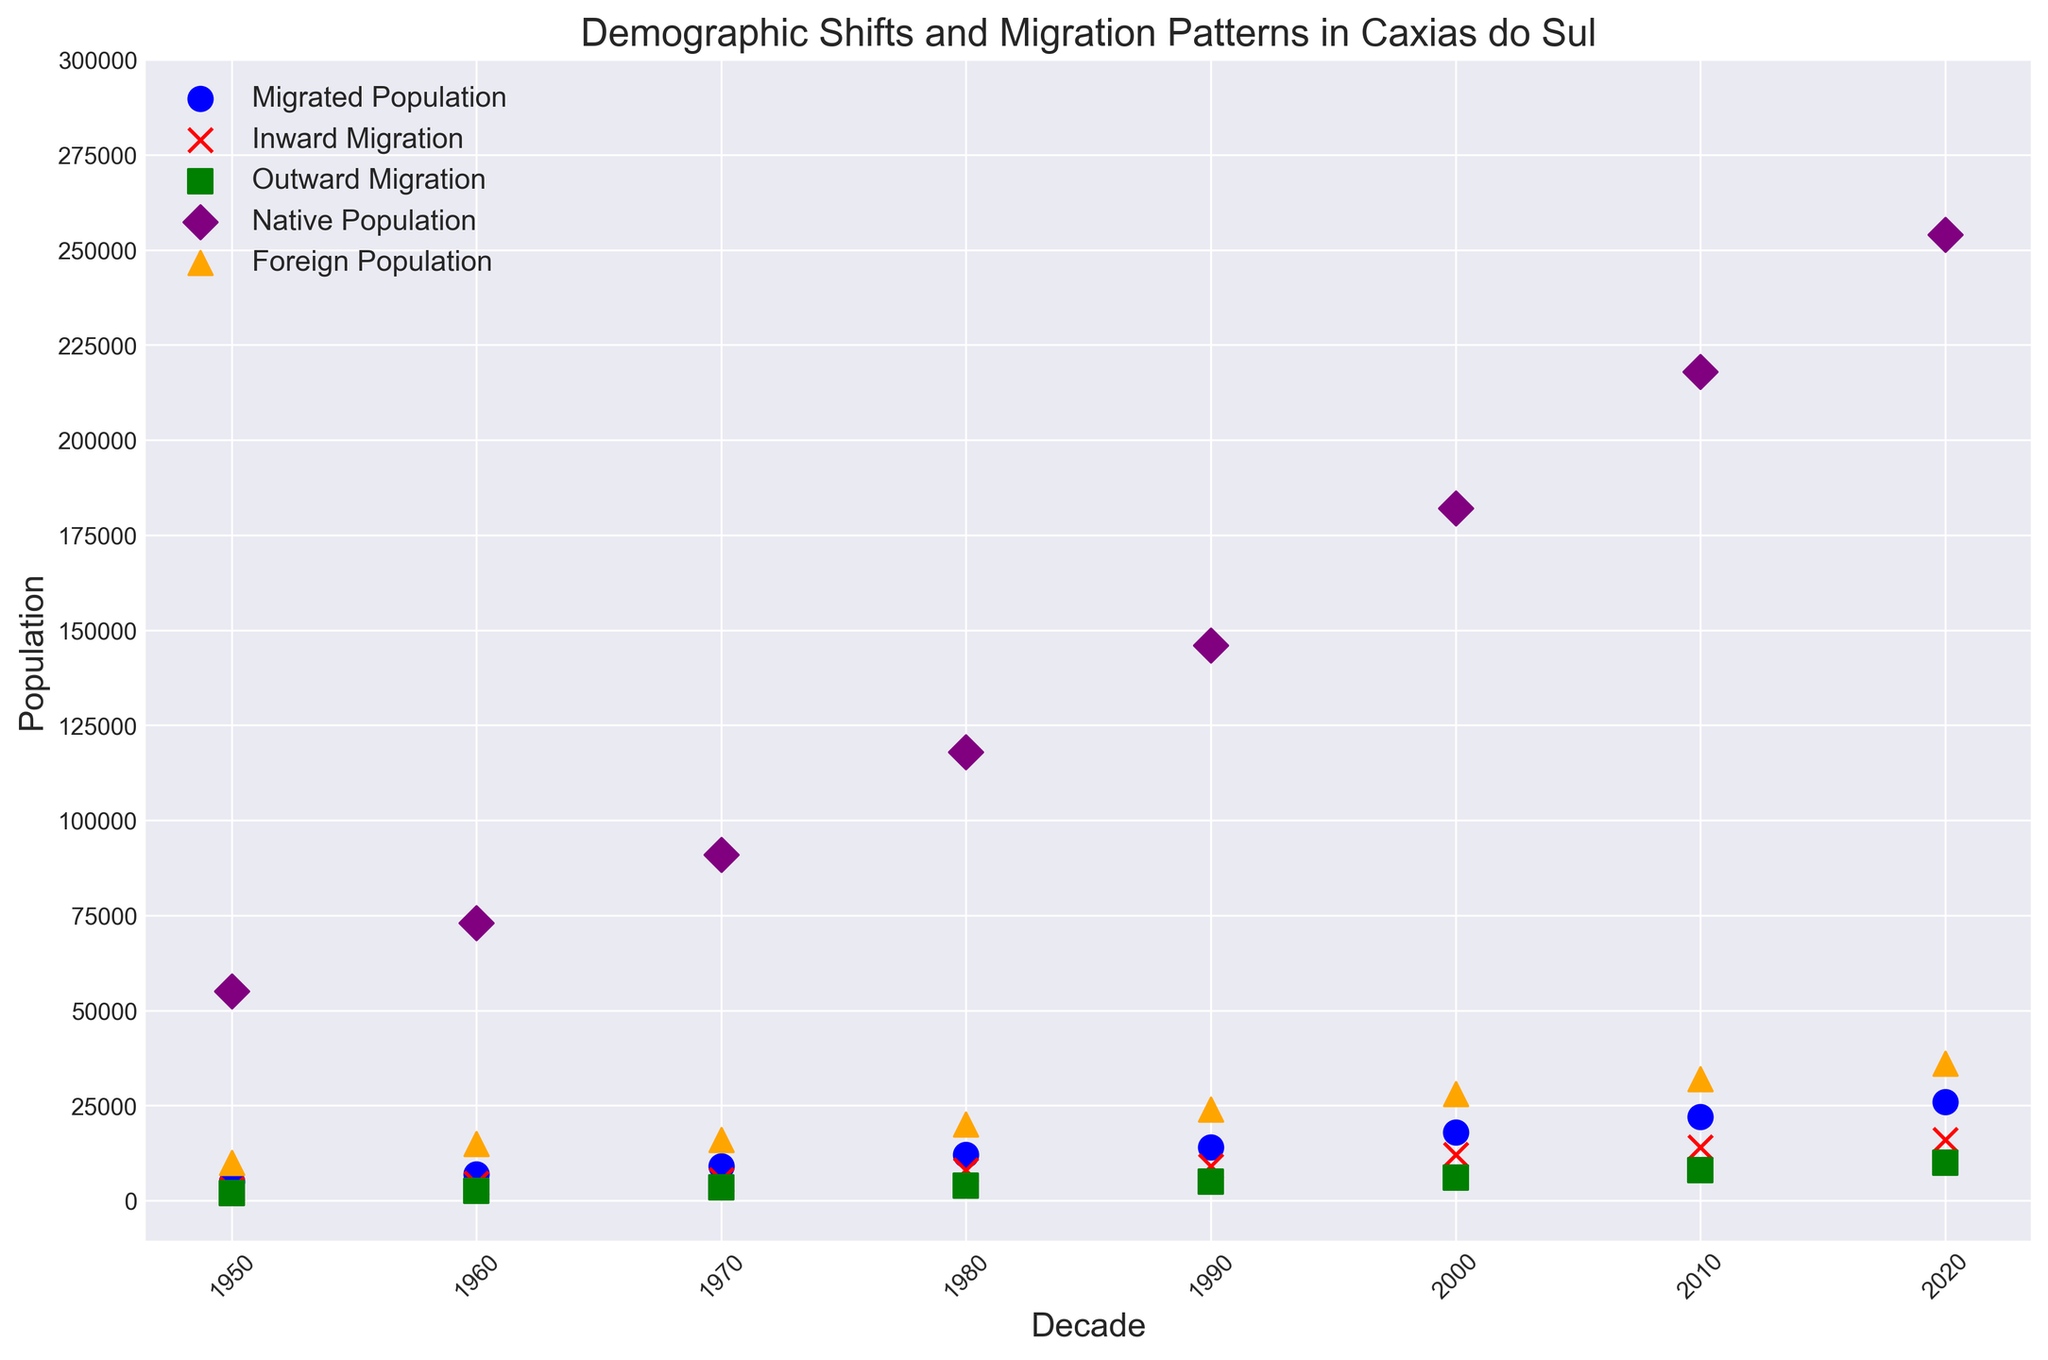What trend do you observe in the total native population from 1950 to 2020? The native population increases steadily in each decade from 1950 to 2020, beginning at 55,000 and reaching 254,000 in 2020.
Answer: There is a consistent increase Compare the inward and outward migration numbers in 1980. Which is higher? In 1980, the inward migration is 8,000, while the outward migration is 4,000.
Answer: Inward migration is higher How much did the foreign population grow between 1970 and 1980? The foreign population in 1970 was 16,000, and in 1980 it was 20,000. The growth is calculated as 20,000 - 16,000 = 4,000.
Answer: 4,000 What is the difference between the migrated population in 1990 and the inward migration in 2020? The migrated population in 1990 is 14,000, and the inward migration in 2020 is 16,000. The difference is 16,000 - 14,000 = 2,000.
Answer: 2,000 In which decade did Caxias do Sul have the highest outward migration? The highest outward migration occurred in the 2020 decade with 10,000 people leaving the city.
Answer: 2020 Which category has the most noticeable increase in the scatter plot by observing the color of the markers? Observing the plot, the native population, represented by purple markers, shows the most noticeable increase over the decades.
Answer: Native population What is the sum of native and foreign populations in 2000? The native population in 2000 is 182,000, and the foreign population is 28,000. The sum is 182,000 + 28,000 = 210,000.
Answer: 210,000 Compare the inward migration between 1950 and 2010. How much did it grow? The inward migration was 3,000 in 1950 and 14,000 in 2010. The growth is calculated as 14,000 - 3,000 = 11,000.
Answer: 11,000 Which decade shows the smallest difference between inward and outward migration? The smallest difference is observed in 1950, with inward migration at 3,000 and outward migration at 2,000, making the difference 1,000.
Answer: 1950 